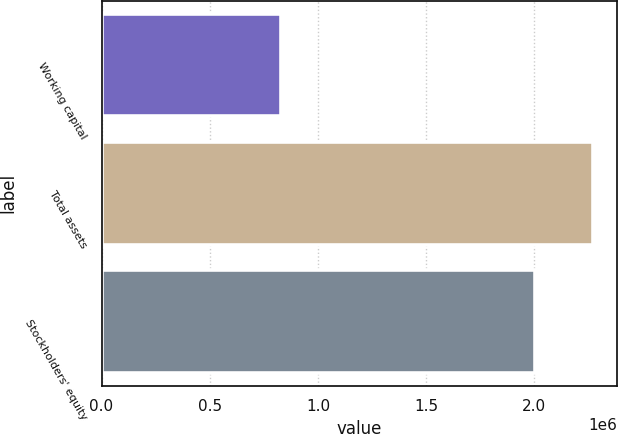<chart> <loc_0><loc_0><loc_500><loc_500><bar_chart><fcel>Working capital<fcel>Total assets<fcel>Stockholders' equity<nl><fcel>828817<fcel>2.26954e+06<fcel>2.00437e+06<nl></chart> 